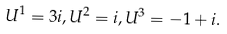<formula> <loc_0><loc_0><loc_500><loc_500>U ^ { 1 } = 3 i , U ^ { 2 } = i , U ^ { 3 } = - 1 + i . \,</formula> 